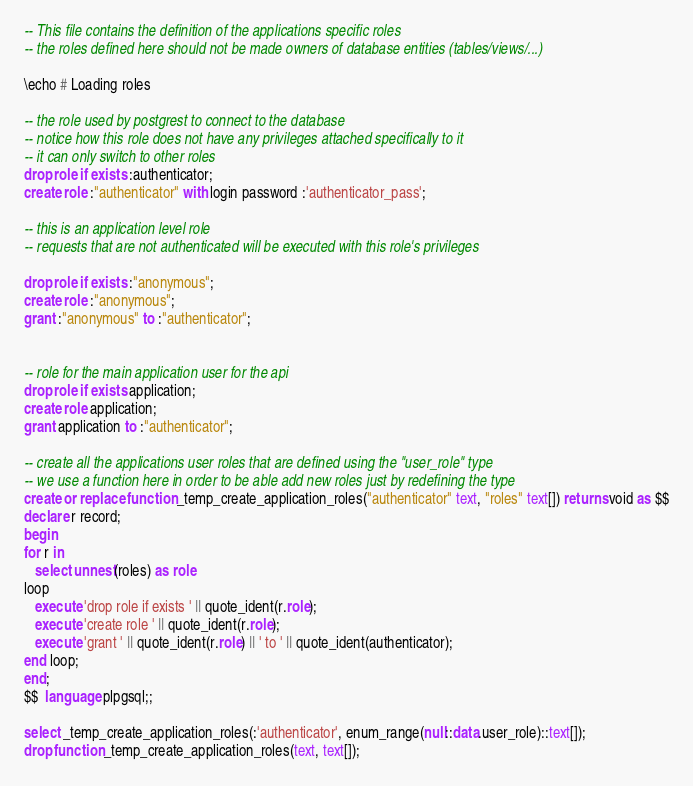<code> <loc_0><loc_0><loc_500><loc_500><_SQL_>-- This file contains the definition of the applications specific roles
-- the roles defined here should not be made owners of database entities (tables/views/...)

\echo # Loading roles

-- the role used by postgrest to connect to the database
-- notice how this role does not have any privileges attached specifically to it
-- it can only switch to other roles
drop role if exists :authenticator;
create role :"authenticator" with login password :'authenticator_pass';

-- this is an application level role
-- requests that are not authenticated will be executed with this role's privileges

drop role if exists :"anonymous";
create role :"anonymous";
grant :"anonymous" to :"authenticator";


-- role for the main application user for the api
drop role if exists application;
create role application;
grant application to :"authenticator";

-- create all the applications user roles that are defined using the "user_role" type
-- we use a function here in order to be able add new roles just by redefining the type
create or replace function _temp_create_application_roles("authenticator" text, "roles" text[]) returns void as $$
declare r record;
begin
for r in
   select unnest(roles) as role
loop
   execute 'drop role if exists ' || quote_ident(r.role);
   execute 'create role ' || quote_ident(r.role);
   execute 'grant ' || quote_ident(r.role) || ' to ' || quote_ident(authenticator);
end loop;
end;
$$  language plpgsql;;

select _temp_create_application_roles(:'authenticator', enum_range(null::data.user_role)::text[]);
drop function _temp_create_application_roles(text, text[]);
</code> 